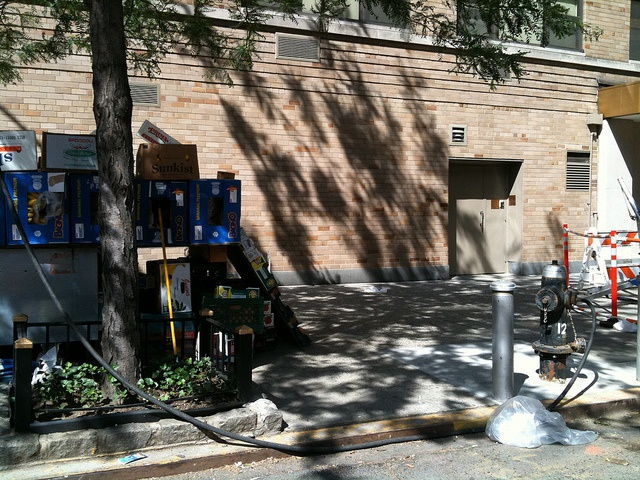Describe the objects in this image and their specific colors. I can see a fire hydrant in black, gray, darkgray, and purple tones in this image. 